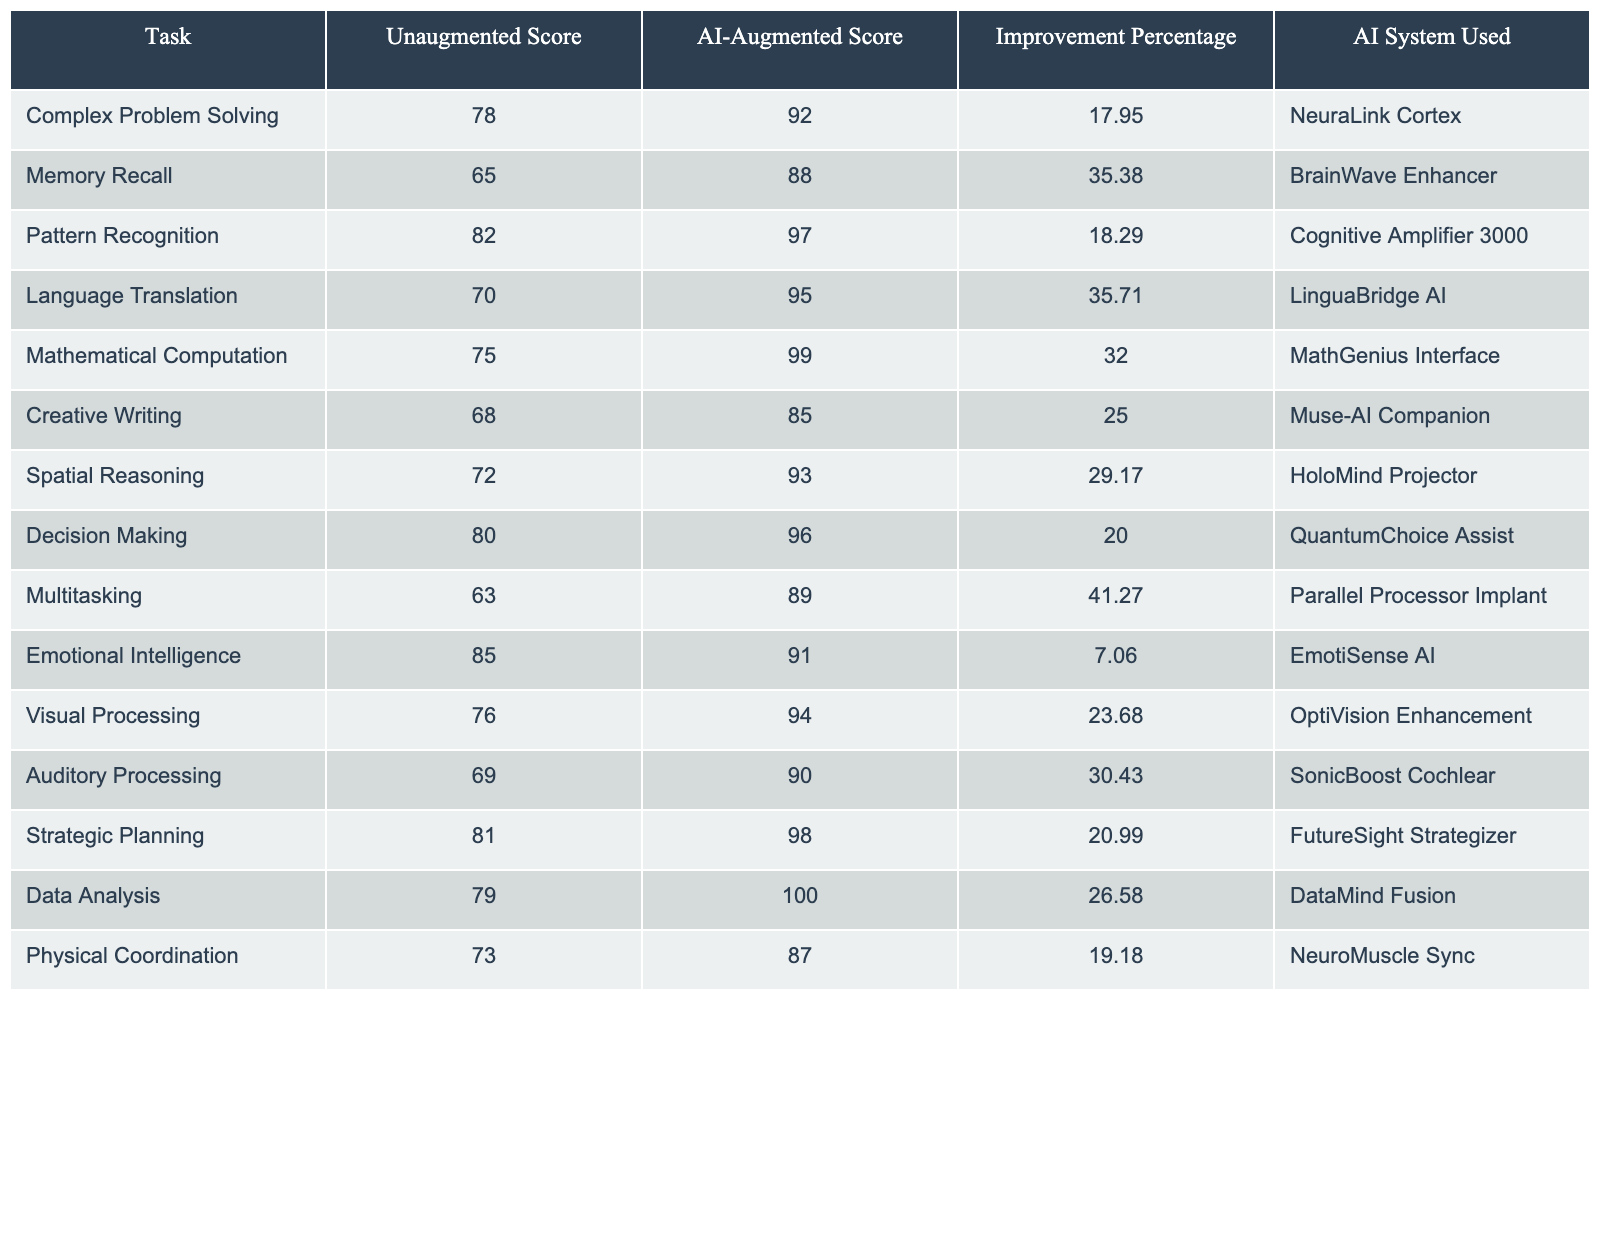What is the AI-augmented score for Memory Recall? The table shows that the AI-augmented score for Memory Recall is listed under the "AI-Augmented Score" column for the corresponding task. It indicates a score of 88.
Answer: 88 Which task has the highest improvement percentage with AI augmentation? By comparing the "Improvement Percentage" column, the highest percentage is 41.27%, which corresponds to the task "Multitasking."
Answer: Multitasking What AI system is used for Creative Writing? The table provides the information in the "AI System Used" column for the task "Creative Writing," which is identified as "Muse-AI Companion."
Answer: Muse-AI Companion Is the AI-augmented score for Emotional Intelligence higher than 90? Looking at the "AI-Augmented Score" column for the task "Emotional Intelligence," it shows a score of 91, which is indeed higher than 90.
Answer: Yes What is the difference between the AI-augmented and unaugmented score for Mathematical Computation? To find the difference, subtract the unaugmented score (75) from the AI-augmented score (99): 99 - 75 = 24. Thus, the difference is 24.
Answer: 24 Which task shows the smallest improvement percentage? Examining the "Improvement Percentage" column, the smallest percentage is 7.06%, which corresponds to "Emotional Intelligence."
Answer: Emotional Intelligence What is the average AI-augmented score across all tasks? To calculate the average, sum all AI-augmented scores: (92 + 88 + 97 + 95 + 99 + 85 + 93 + 96 + 89 + 91 + 94 + 90 + 98 + 100 + 87) = 1373. There are 15 tasks, so the average is 1373 / 15 ≈ 91.53.
Answer: 91.53 If a human was augmented using the Cognitive Amplifier 3000, what task's improvement percentage would they experience? Looking up the "Improvement Percentage" column for "Pattern Recognition," which uses the Cognitive Amplifier 3000, the improvement percentage is 18.29%.
Answer: 18.29% Which two tasks have AI-augmented scores closest to each other? Observing the AI-augmented scores, Memory Recall (88) and Emotional Intelligence (91) are the closest. The difference is 3 points.
Answer: Memory Recall and Emotional Intelligence What is the unaugmented score for Spatial Reasoning? The table states the unaugmented score for Spatial Reasoning in the respective column, which is 72.
Answer: 72 Does the AI-augmented score for Language Translation have a higher improvement percentage than that for Data Analysis? The improvement percentage for Language Translation is 35.71%, and for Data Analysis, it is 26.58%. Since 35.71% is greater than 26.58%, the answer is yes.
Answer: Yes 